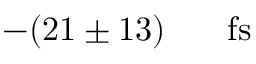<formula> <loc_0><loc_0><loc_500><loc_500>- ( 2 1 \pm 1 3 ) { { \, } } { f s }</formula> 